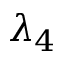Convert formula to latex. <formula><loc_0><loc_0><loc_500><loc_500>\lambda _ { 4 }</formula> 